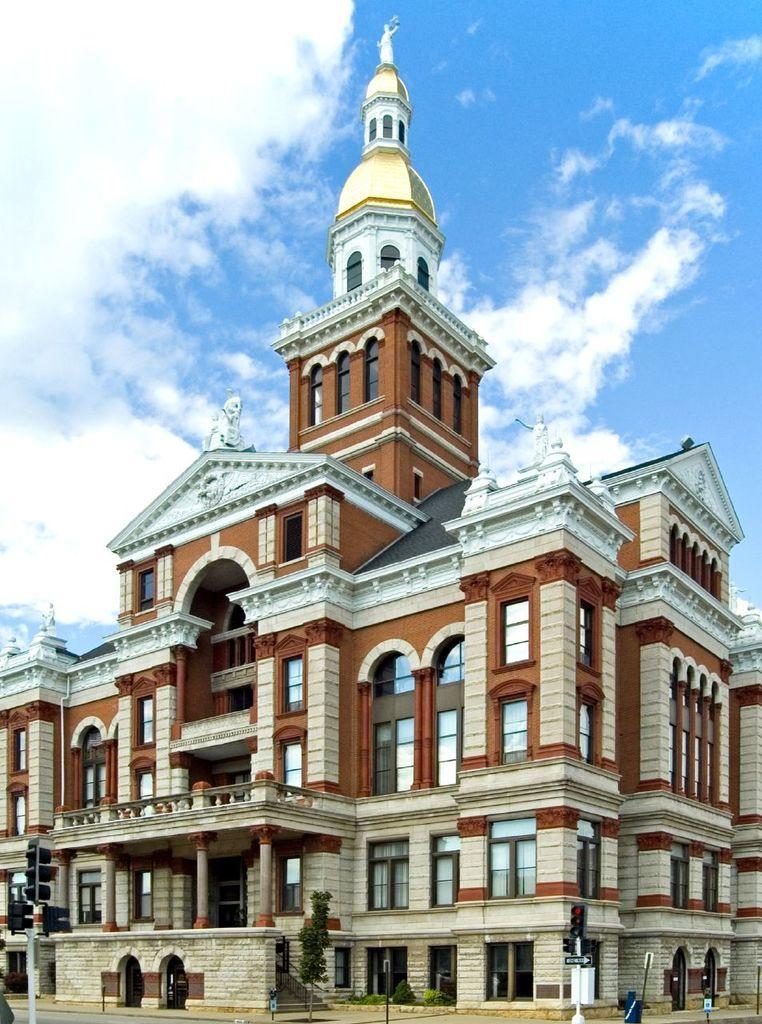In one or two sentences, can you explain what this image depicts? This image consists of a building in brown color. At the top, there are clouds in the sky. This buildings consists of many windows and door along with the pillars. 